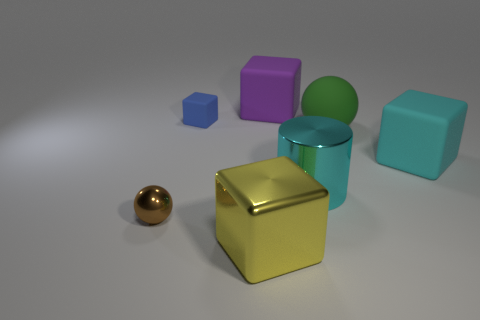Subtract all rubber blocks. How many blocks are left? 1 Subtract all yellow blocks. How many blocks are left? 3 Add 1 large purple things. How many objects exist? 8 Subtract 2 cubes. How many cubes are left? 2 Subtract all blocks. How many objects are left? 3 Subtract all brown blocks. Subtract all purple spheres. How many blocks are left? 4 Subtract all cyan metallic things. Subtract all big yellow metal things. How many objects are left? 5 Add 5 big yellow metallic objects. How many big yellow metallic objects are left? 6 Add 4 big matte objects. How many big matte objects exist? 7 Subtract 1 purple cubes. How many objects are left? 6 